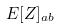Convert formula to latex. <formula><loc_0><loc_0><loc_500><loc_500>E [ Z ] _ { a b }</formula> 